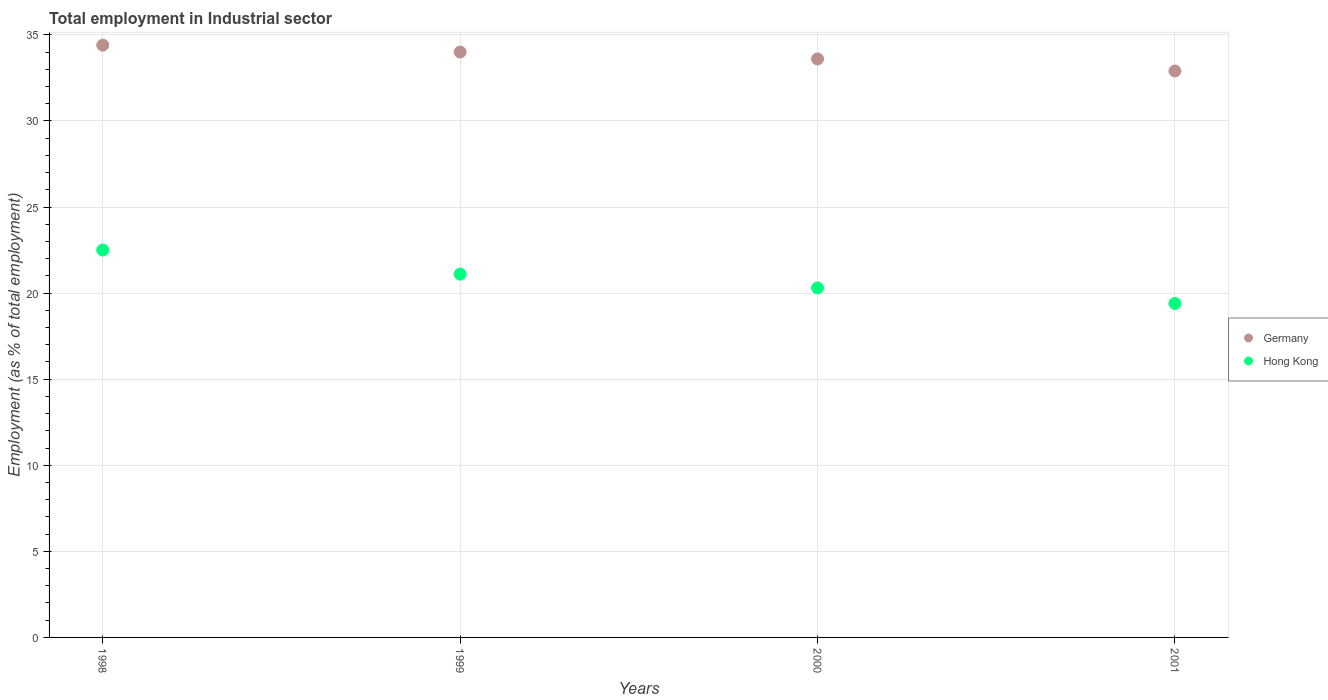How many different coloured dotlines are there?
Your response must be concise. 2. Is the number of dotlines equal to the number of legend labels?
Your response must be concise. Yes. What is the employment in industrial sector in Hong Kong in 2000?
Ensure brevity in your answer.  20.3. Across all years, what is the maximum employment in industrial sector in Hong Kong?
Provide a succinct answer. 22.5. Across all years, what is the minimum employment in industrial sector in Germany?
Make the answer very short. 32.9. In which year was the employment in industrial sector in Hong Kong maximum?
Offer a terse response. 1998. In which year was the employment in industrial sector in Hong Kong minimum?
Offer a terse response. 2001. What is the total employment in industrial sector in Germany in the graph?
Make the answer very short. 134.9. What is the difference between the employment in industrial sector in Hong Kong in 1999 and that in 2001?
Provide a succinct answer. 1.7. What is the difference between the employment in industrial sector in Hong Kong in 1999 and the employment in industrial sector in Germany in 2001?
Your response must be concise. -11.8. What is the average employment in industrial sector in Germany per year?
Make the answer very short. 33.73. In the year 1999, what is the difference between the employment in industrial sector in Germany and employment in industrial sector in Hong Kong?
Provide a short and direct response. 12.9. In how many years, is the employment in industrial sector in Germany greater than 12 %?
Your answer should be compact. 4. What is the ratio of the employment in industrial sector in Germany in 1998 to that in 1999?
Provide a succinct answer. 1.01. Is the employment in industrial sector in Germany in 1998 less than that in 2001?
Provide a succinct answer. No. Is the difference between the employment in industrial sector in Germany in 1999 and 2000 greater than the difference between the employment in industrial sector in Hong Kong in 1999 and 2000?
Your answer should be compact. No. What is the difference between the highest and the second highest employment in industrial sector in Hong Kong?
Give a very brief answer. 1.4. Is the sum of the employment in industrial sector in Hong Kong in 1998 and 1999 greater than the maximum employment in industrial sector in Germany across all years?
Provide a succinct answer. Yes. Is the employment in industrial sector in Germany strictly greater than the employment in industrial sector in Hong Kong over the years?
Offer a very short reply. Yes. What is the difference between two consecutive major ticks on the Y-axis?
Your answer should be very brief. 5. Does the graph contain any zero values?
Provide a short and direct response. No. Where does the legend appear in the graph?
Offer a very short reply. Center right. What is the title of the graph?
Give a very brief answer. Total employment in Industrial sector. What is the label or title of the X-axis?
Your response must be concise. Years. What is the label or title of the Y-axis?
Provide a short and direct response. Employment (as % of total employment). What is the Employment (as % of total employment) in Germany in 1998?
Offer a very short reply. 34.4. What is the Employment (as % of total employment) in Hong Kong in 1999?
Ensure brevity in your answer.  21.1. What is the Employment (as % of total employment) in Germany in 2000?
Keep it short and to the point. 33.6. What is the Employment (as % of total employment) of Hong Kong in 2000?
Your response must be concise. 20.3. What is the Employment (as % of total employment) of Germany in 2001?
Ensure brevity in your answer.  32.9. What is the Employment (as % of total employment) in Hong Kong in 2001?
Offer a terse response. 19.4. Across all years, what is the maximum Employment (as % of total employment) in Germany?
Offer a terse response. 34.4. Across all years, what is the maximum Employment (as % of total employment) of Hong Kong?
Give a very brief answer. 22.5. Across all years, what is the minimum Employment (as % of total employment) of Germany?
Keep it short and to the point. 32.9. Across all years, what is the minimum Employment (as % of total employment) of Hong Kong?
Your answer should be compact. 19.4. What is the total Employment (as % of total employment) of Germany in the graph?
Your answer should be very brief. 134.9. What is the total Employment (as % of total employment) in Hong Kong in the graph?
Give a very brief answer. 83.3. What is the difference between the Employment (as % of total employment) in Hong Kong in 1998 and that in 1999?
Offer a very short reply. 1.4. What is the difference between the Employment (as % of total employment) in Germany in 1998 and that in 2000?
Your response must be concise. 0.8. What is the difference between the Employment (as % of total employment) of Germany in 1998 and that in 2001?
Ensure brevity in your answer.  1.5. What is the difference between the Employment (as % of total employment) of Hong Kong in 1998 and that in 2001?
Your answer should be compact. 3.1. What is the difference between the Employment (as % of total employment) of Hong Kong in 1999 and that in 2000?
Ensure brevity in your answer.  0.8. What is the difference between the Employment (as % of total employment) in Germany in 1999 and that in 2001?
Ensure brevity in your answer.  1.1. What is the difference between the Employment (as % of total employment) in Hong Kong in 1999 and that in 2001?
Offer a terse response. 1.7. What is the difference between the Employment (as % of total employment) in Hong Kong in 2000 and that in 2001?
Make the answer very short. 0.9. What is the difference between the Employment (as % of total employment) of Germany in 2000 and the Employment (as % of total employment) of Hong Kong in 2001?
Provide a short and direct response. 14.2. What is the average Employment (as % of total employment) of Germany per year?
Give a very brief answer. 33.73. What is the average Employment (as % of total employment) of Hong Kong per year?
Offer a very short reply. 20.82. In the year 2000, what is the difference between the Employment (as % of total employment) in Germany and Employment (as % of total employment) in Hong Kong?
Give a very brief answer. 13.3. In the year 2001, what is the difference between the Employment (as % of total employment) of Germany and Employment (as % of total employment) of Hong Kong?
Make the answer very short. 13.5. What is the ratio of the Employment (as % of total employment) of Germany in 1998 to that in 1999?
Your response must be concise. 1.01. What is the ratio of the Employment (as % of total employment) of Hong Kong in 1998 to that in 1999?
Your answer should be compact. 1.07. What is the ratio of the Employment (as % of total employment) of Germany in 1998 to that in 2000?
Your answer should be very brief. 1.02. What is the ratio of the Employment (as % of total employment) in Hong Kong in 1998 to that in 2000?
Ensure brevity in your answer.  1.11. What is the ratio of the Employment (as % of total employment) in Germany in 1998 to that in 2001?
Offer a very short reply. 1.05. What is the ratio of the Employment (as % of total employment) of Hong Kong in 1998 to that in 2001?
Provide a succinct answer. 1.16. What is the ratio of the Employment (as % of total employment) in Germany in 1999 to that in 2000?
Keep it short and to the point. 1.01. What is the ratio of the Employment (as % of total employment) in Hong Kong in 1999 to that in 2000?
Give a very brief answer. 1.04. What is the ratio of the Employment (as % of total employment) of Germany in 1999 to that in 2001?
Offer a terse response. 1.03. What is the ratio of the Employment (as % of total employment) in Hong Kong in 1999 to that in 2001?
Provide a short and direct response. 1.09. What is the ratio of the Employment (as % of total employment) of Germany in 2000 to that in 2001?
Your answer should be very brief. 1.02. What is the ratio of the Employment (as % of total employment) of Hong Kong in 2000 to that in 2001?
Your response must be concise. 1.05. What is the difference between the highest and the second highest Employment (as % of total employment) of Hong Kong?
Provide a short and direct response. 1.4. What is the difference between the highest and the lowest Employment (as % of total employment) of Hong Kong?
Ensure brevity in your answer.  3.1. 